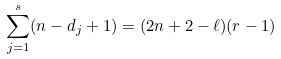Convert formula to latex. <formula><loc_0><loc_0><loc_500><loc_500>\sum _ { j = 1 } ^ { s } ( n - d _ { j } + 1 ) = ( 2 n + 2 - \ell ) ( r - 1 )</formula> 